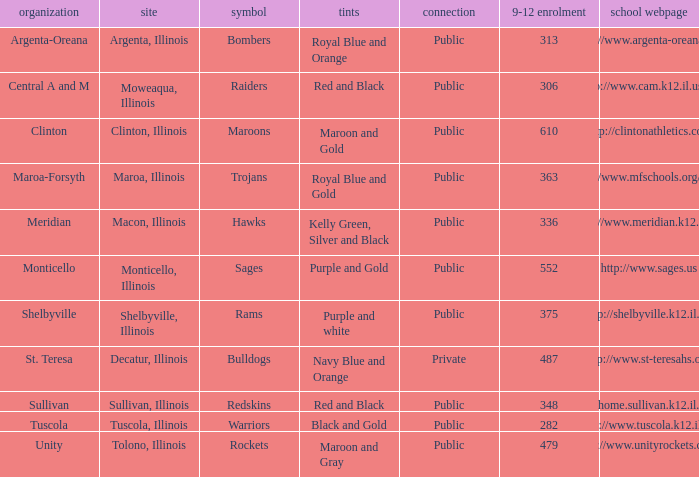What are the team colors from Tolono, Illinois? Maroon and Gray. 